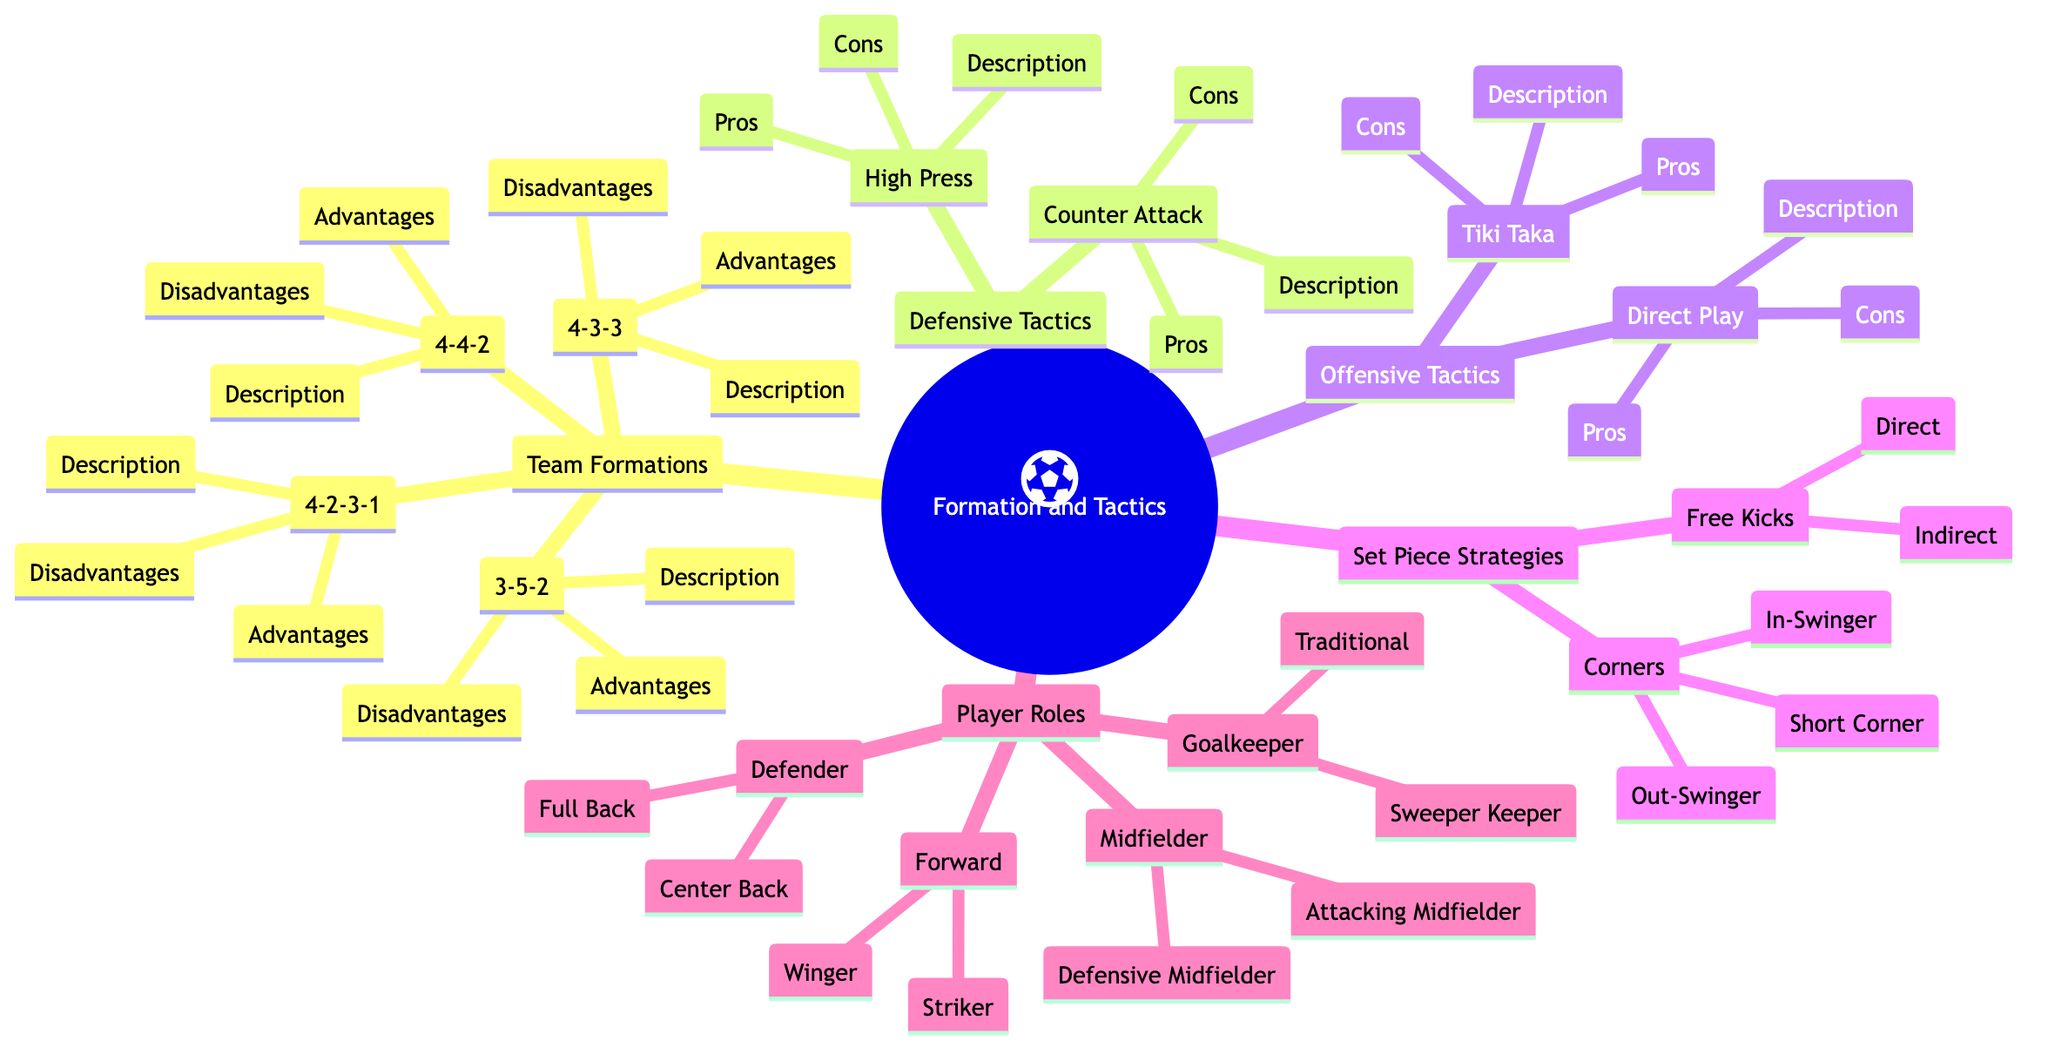What is the description of the 4-2-3-1 formation? The description for the 4-2-3-1 formation is located under its respective node in the Team Formations section of the diagram. It states that it consists of four defenders, two holding midfielders, three attacking midfielders, and one striker.
Answer: Four defenders, two holding midfielders, three attacking midfielders, one striker How many player roles are listed in the diagram? To find the answer, count the distinct categories under Player Roles. There are four categories: Goalkeeper, Defender, Midfielder, and Forward, which totals to four player roles.
Answer: Four What is an advantage of the 3-5-2 formation? The advantages of the 3-5-2 formation are described under its node in the Team Formations section. It specifically states that one of its advantages is a strong midfield presence and solid defense with wing-back support.
Answer: Strong midfield presence and solid defense with wing-back support What are the pros of using the Tiki Taka tactic? The pros of Tiki Taka are detailed under the Offensive Tactics section. It mentions that it maintains high possession and control of the match as its main advantage.
Answer: Maintains high possession and control of the match Which set piece strategy involves a ball curved towards the goal from a corner kick? This is specified under Corners in the Set Piece Strategies section. The In-Swinger is defined as the ball curved towards the goal from the corner kick.
Answer: In-Swinger What is a con of the Direct Play tactic? The con of the Direct Play tactic is mentioned under the Offensive Tactics section. It indicates that if not well-executed, it can lead to a loss of possession.
Answer: Can lead to loss of possession if not well-executed How many types of player roles are identified under the Defender category? By examining the Defender category under Player Roles, there are two specific types identified: Center Back and Full Back, which indicates a total of two types of defender roles.
Answer: Two What does the High Press tactic aim to do? The description of the High Press tactic is found in the Defensive Tactics section. It explains that the tactic aims to aggressively press opponents high up the pitch to regain possession quickly.
Answer: Regain possession quickly 